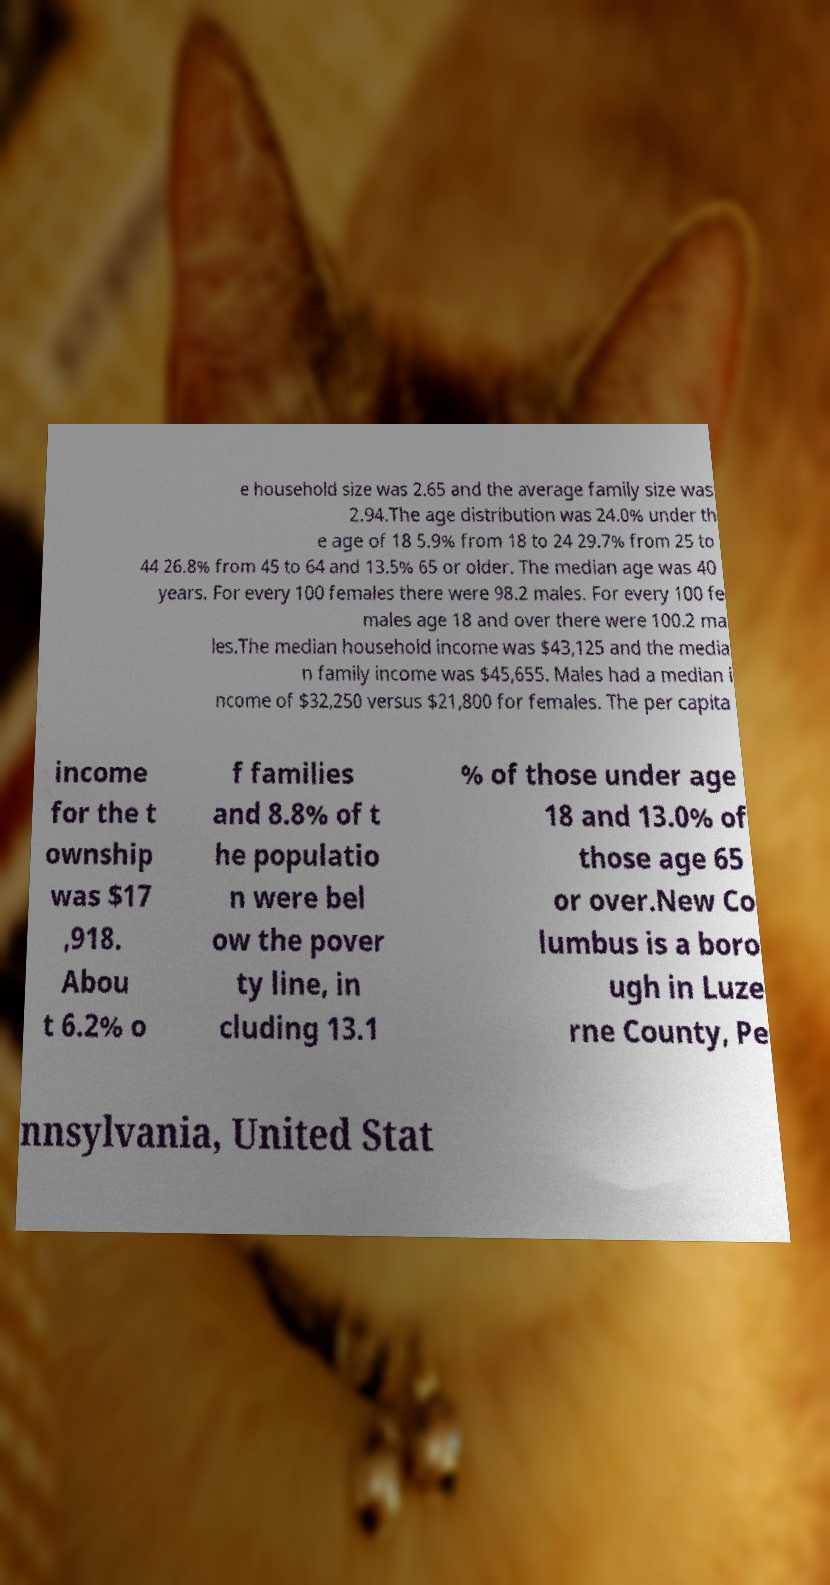What messages or text are displayed in this image? I need them in a readable, typed format. e household size was 2.65 and the average family size was 2.94.The age distribution was 24.0% under th e age of 18 5.9% from 18 to 24 29.7% from 25 to 44 26.8% from 45 to 64 and 13.5% 65 or older. The median age was 40 years. For every 100 females there were 98.2 males. For every 100 fe males age 18 and over there were 100.2 ma les.The median household income was $43,125 and the media n family income was $45,655. Males had a median i ncome of $32,250 versus $21,800 for females. The per capita income for the t ownship was $17 ,918. Abou t 6.2% o f families and 8.8% of t he populatio n were bel ow the pover ty line, in cluding 13.1 % of those under age 18 and 13.0% of those age 65 or over.New Co lumbus is a boro ugh in Luze rne County, Pe nnsylvania, United Stat 